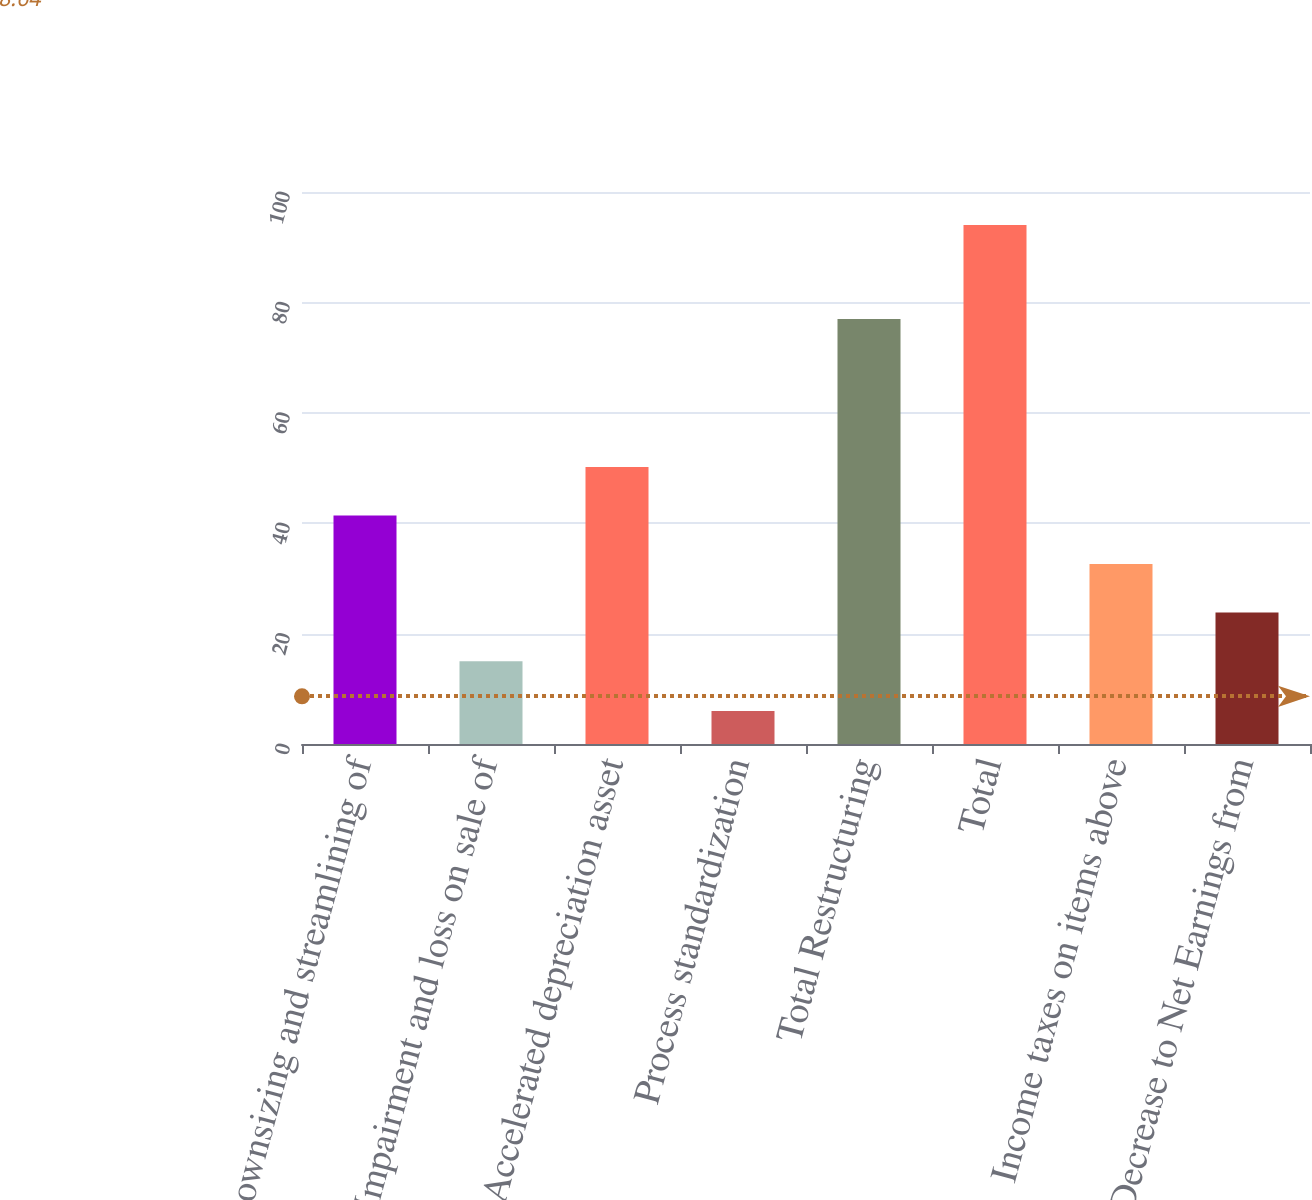Convert chart to OTSL. <chart><loc_0><loc_0><loc_500><loc_500><bar_chart><fcel>Downsizing and streamlining of<fcel>Impairment and loss on sale of<fcel>Accelerated depreciation asset<fcel>Process standardization<fcel>Total Restructuring<fcel>Total<fcel>Income taxes on items above<fcel>Decrease to Net Earnings from<nl><fcel>41.4<fcel>15<fcel>50.2<fcel>6<fcel>77<fcel>94<fcel>32.6<fcel>23.8<nl></chart> 